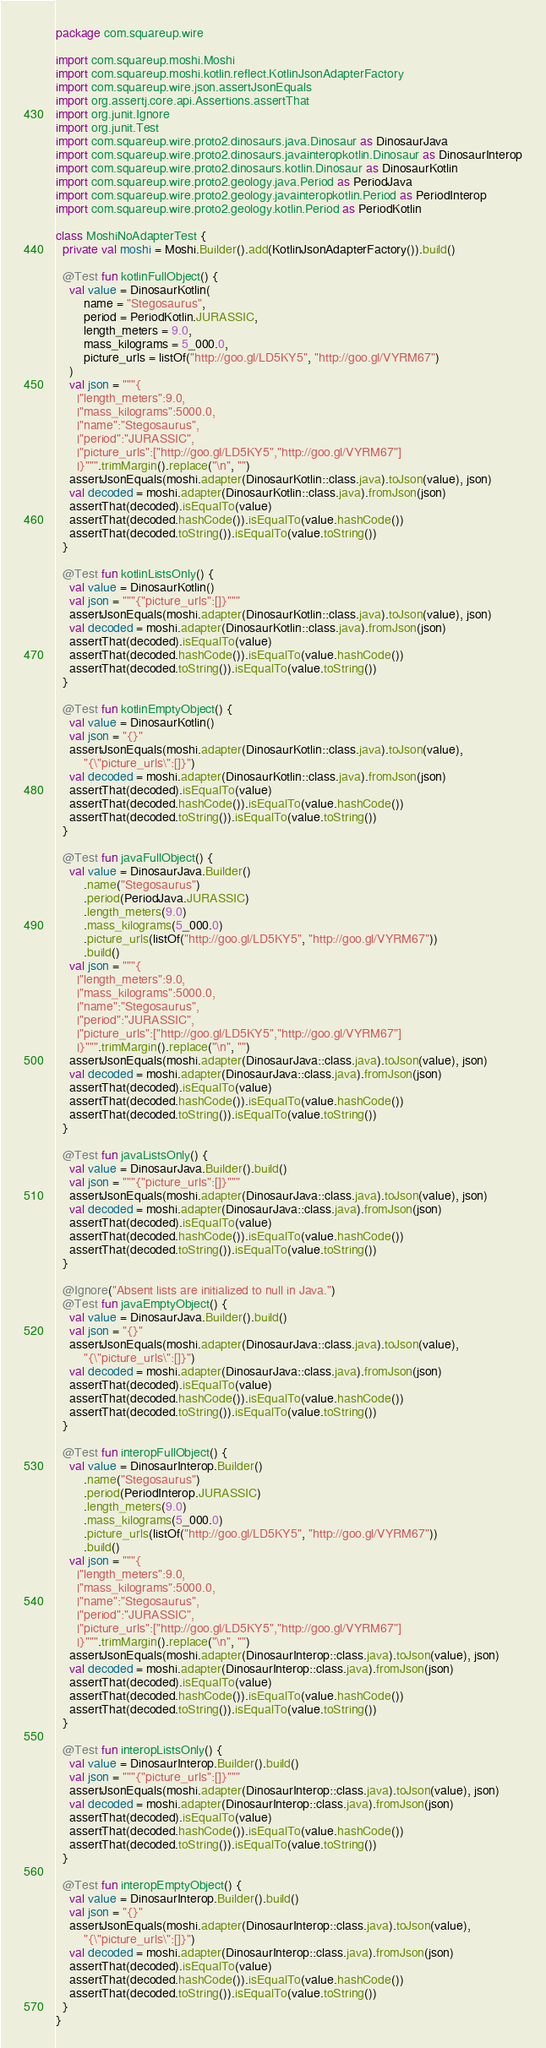<code> <loc_0><loc_0><loc_500><loc_500><_Kotlin_>package com.squareup.wire

import com.squareup.moshi.Moshi
import com.squareup.moshi.kotlin.reflect.KotlinJsonAdapterFactory
import com.squareup.wire.json.assertJsonEquals
import org.assertj.core.api.Assertions.assertThat
import org.junit.Ignore
import org.junit.Test
import com.squareup.wire.proto2.dinosaurs.java.Dinosaur as DinosaurJava
import com.squareup.wire.proto2.dinosaurs.javainteropkotlin.Dinosaur as DinosaurInterop
import com.squareup.wire.proto2.dinosaurs.kotlin.Dinosaur as DinosaurKotlin
import com.squareup.wire.proto2.geology.java.Period as PeriodJava
import com.squareup.wire.proto2.geology.javainteropkotlin.Period as PeriodInterop
import com.squareup.wire.proto2.geology.kotlin.Period as PeriodKotlin

class MoshiNoAdapterTest {
  private val moshi = Moshi.Builder().add(KotlinJsonAdapterFactory()).build()

  @Test fun kotlinFullObject() {
    val value = DinosaurKotlin(
        name = "Stegosaurus",
        period = PeriodKotlin.JURASSIC,
        length_meters = 9.0,
        mass_kilograms = 5_000.0,
        picture_urls = listOf("http://goo.gl/LD5KY5", "http://goo.gl/VYRM67")
    )
    val json = """{
      |"length_meters":9.0,
      |"mass_kilograms":5000.0,
      |"name":"Stegosaurus",
      |"period":"JURASSIC",
      |"picture_urls":["http://goo.gl/LD5KY5","http://goo.gl/VYRM67"]
      |}""".trimMargin().replace("\n", "")
    assertJsonEquals(moshi.adapter(DinosaurKotlin::class.java).toJson(value), json)
    val decoded = moshi.adapter(DinosaurKotlin::class.java).fromJson(json)
    assertThat(decoded).isEqualTo(value)
    assertThat(decoded.hashCode()).isEqualTo(value.hashCode())
    assertThat(decoded.toString()).isEqualTo(value.toString())
  }

  @Test fun kotlinListsOnly() {
    val value = DinosaurKotlin()
    val json = """{"picture_urls":[]}"""
    assertJsonEquals(moshi.adapter(DinosaurKotlin::class.java).toJson(value), json)
    val decoded = moshi.adapter(DinosaurKotlin::class.java).fromJson(json)
    assertThat(decoded).isEqualTo(value)
    assertThat(decoded.hashCode()).isEqualTo(value.hashCode())
    assertThat(decoded.toString()).isEqualTo(value.toString())
  }

  @Test fun kotlinEmptyObject() {
    val value = DinosaurKotlin()
    val json = "{}"
    assertJsonEquals(moshi.adapter(DinosaurKotlin::class.java).toJson(value),
        "{\"picture_urls\":[]}")
    val decoded = moshi.adapter(DinosaurKotlin::class.java).fromJson(json)
    assertThat(decoded).isEqualTo(value)
    assertThat(decoded.hashCode()).isEqualTo(value.hashCode())
    assertThat(decoded.toString()).isEqualTo(value.toString())
  }

  @Test fun javaFullObject() {
    val value = DinosaurJava.Builder()
        .name("Stegosaurus")
        .period(PeriodJava.JURASSIC)
        .length_meters(9.0)
        .mass_kilograms(5_000.0)
        .picture_urls(listOf("http://goo.gl/LD5KY5", "http://goo.gl/VYRM67"))
        .build()
    val json = """{
      |"length_meters":9.0,
      |"mass_kilograms":5000.0,
      |"name":"Stegosaurus",
      |"period":"JURASSIC",
      |"picture_urls":["http://goo.gl/LD5KY5","http://goo.gl/VYRM67"]
      |}""".trimMargin().replace("\n", "")
    assertJsonEquals(moshi.adapter(DinosaurJava::class.java).toJson(value), json)
    val decoded = moshi.adapter(DinosaurJava::class.java).fromJson(json)
    assertThat(decoded).isEqualTo(value)
    assertThat(decoded.hashCode()).isEqualTo(value.hashCode())
    assertThat(decoded.toString()).isEqualTo(value.toString())
  }

  @Test fun javaListsOnly() {
    val value = DinosaurJava.Builder().build()
    val json = """{"picture_urls":[]}"""
    assertJsonEquals(moshi.adapter(DinosaurJava::class.java).toJson(value), json)
    val decoded = moshi.adapter(DinosaurJava::class.java).fromJson(json)
    assertThat(decoded).isEqualTo(value)
    assertThat(decoded.hashCode()).isEqualTo(value.hashCode())
    assertThat(decoded.toString()).isEqualTo(value.toString())
  }

  @Ignore("Absent lists are initialized to null in Java.")
  @Test fun javaEmptyObject() {
    val value = DinosaurJava.Builder().build()
    val json = "{}"
    assertJsonEquals(moshi.adapter(DinosaurJava::class.java).toJson(value),
        "{\"picture_urls\":[]}")
    val decoded = moshi.adapter(DinosaurJava::class.java).fromJson(json)
    assertThat(decoded).isEqualTo(value)
    assertThat(decoded.hashCode()).isEqualTo(value.hashCode())
    assertThat(decoded.toString()).isEqualTo(value.toString())
  }

  @Test fun interopFullObject() {
    val value = DinosaurInterop.Builder()
        .name("Stegosaurus")
        .period(PeriodInterop.JURASSIC)
        .length_meters(9.0)
        .mass_kilograms(5_000.0)
        .picture_urls(listOf("http://goo.gl/LD5KY5", "http://goo.gl/VYRM67"))
        .build()
    val json = """{
      |"length_meters":9.0,
      |"mass_kilograms":5000.0,
      |"name":"Stegosaurus",
      |"period":"JURASSIC",
      |"picture_urls":["http://goo.gl/LD5KY5","http://goo.gl/VYRM67"]
      |}""".trimMargin().replace("\n", "")
    assertJsonEquals(moshi.adapter(DinosaurInterop::class.java).toJson(value), json)
    val decoded = moshi.adapter(DinosaurInterop::class.java).fromJson(json)
    assertThat(decoded).isEqualTo(value)
    assertThat(decoded.hashCode()).isEqualTo(value.hashCode())
    assertThat(decoded.toString()).isEqualTo(value.toString())
  }

  @Test fun interopListsOnly() {
    val value = DinosaurInterop.Builder().build()
    val json = """{"picture_urls":[]}"""
    assertJsonEquals(moshi.adapter(DinosaurInterop::class.java).toJson(value), json)
    val decoded = moshi.adapter(DinosaurInterop::class.java).fromJson(json)
    assertThat(decoded).isEqualTo(value)
    assertThat(decoded.hashCode()).isEqualTo(value.hashCode())
    assertThat(decoded.toString()).isEqualTo(value.toString())
  }

  @Test fun interopEmptyObject() {
    val value = DinosaurInterop.Builder().build()
    val json = "{}"
    assertJsonEquals(moshi.adapter(DinosaurInterop::class.java).toJson(value),
        "{\"picture_urls\":[]}")
    val decoded = moshi.adapter(DinosaurInterop::class.java).fromJson(json)
    assertThat(decoded).isEqualTo(value)
    assertThat(decoded.hashCode()).isEqualTo(value.hashCode())
    assertThat(decoded.toString()).isEqualTo(value.toString())
  }
}
</code> 